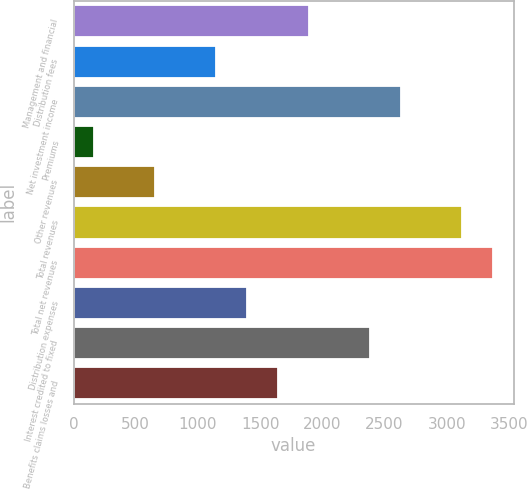Convert chart to OTSL. <chart><loc_0><loc_0><loc_500><loc_500><bar_chart><fcel>Management and financial<fcel>Distribution fees<fcel>Net investment income<fcel>Premiums<fcel>Other revenues<fcel>Total revenues<fcel>Total net revenues<fcel>Distribution expenses<fcel>Interest credited to fixed<fcel>Benefits claims losses and<nl><fcel>1889.3<fcel>1148.6<fcel>2630<fcel>161<fcel>654.8<fcel>3123.8<fcel>3370.7<fcel>1395.5<fcel>2383.1<fcel>1642.4<nl></chart> 